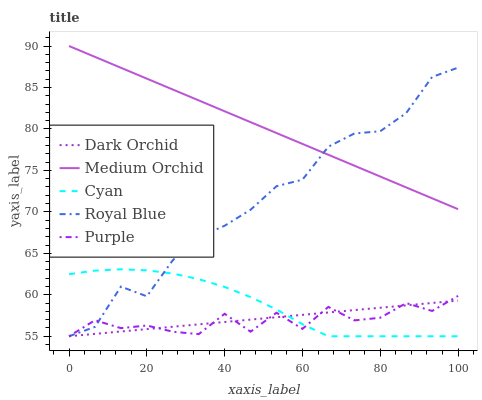Does Cyan have the minimum area under the curve?
Answer yes or no. No. Does Cyan have the maximum area under the curve?
Answer yes or no. No. Is Cyan the smoothest?
Answer yes or no. No. Is Cyan the roughest?
Answer yes or no. No. Does Medium Orchid have the lowest value?
Answer yes or no. No. Does Cyan have the highest value?
Answer yes or no. No. Is Dark Orchid less than Medium Orchid?
Answer yes or no. Yes. Is Medium Orchid greater than Cyan?
Answer yes or no. Yes. Does Dark Orchid intersect Medium Orchid?
Answer yes or no. No. 